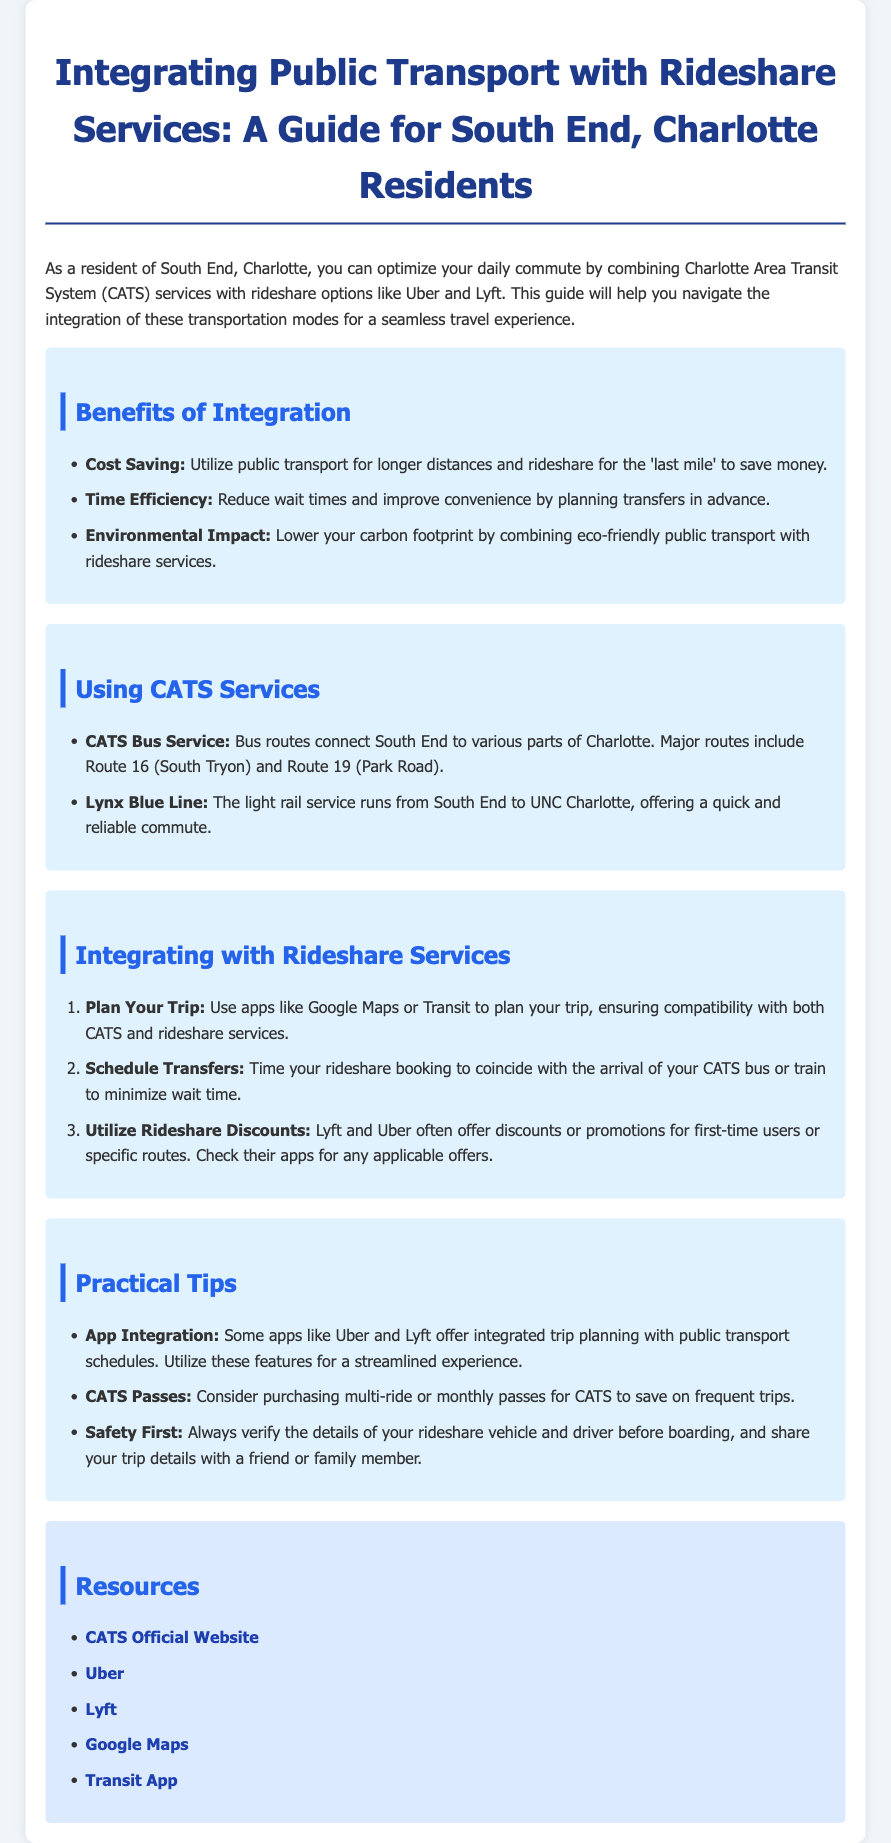What are the two rideshare services mentioned? The document mentions Uber and Lyft as rideshare services.
Answer: Uber, Lyft What is Route 16? Route 16 is one of the major CATS bus routes connecting South End to various parts of Charlotte.
Answer: South Tryon What does the abbreviation CATS stand for? CATS stands for Charlotte Area Transit System.
Answer: Charlotte Area Transit System What is the benefit of using CATS and rideshare integration for environmental impact? The integration lowers your carbon footprint by combining eco-friendly public transport with rideshare services.
Answer: Lower carbon footprint What should you use to plan your trip? The document suggests using apps like Google Maps or Transit to plan your trip.
Answer: Google Maps or Transit How can you reduce wait times when using rideshare with CATS? You can reduce wait times by timing your rideshare booking to coincide with the arrival of your CATS bus or train.
Answer: Minimize wait time What type of tips are provided in the document? The tips focus on practical advice for integrating public transport with rideshare services.
Answer: Practical Tips How can you save money on CATS services? Purchasing multi-ride or monthly passes for CATS can help save on frequent trips.
Answer: Multi-ride or monthly passes 